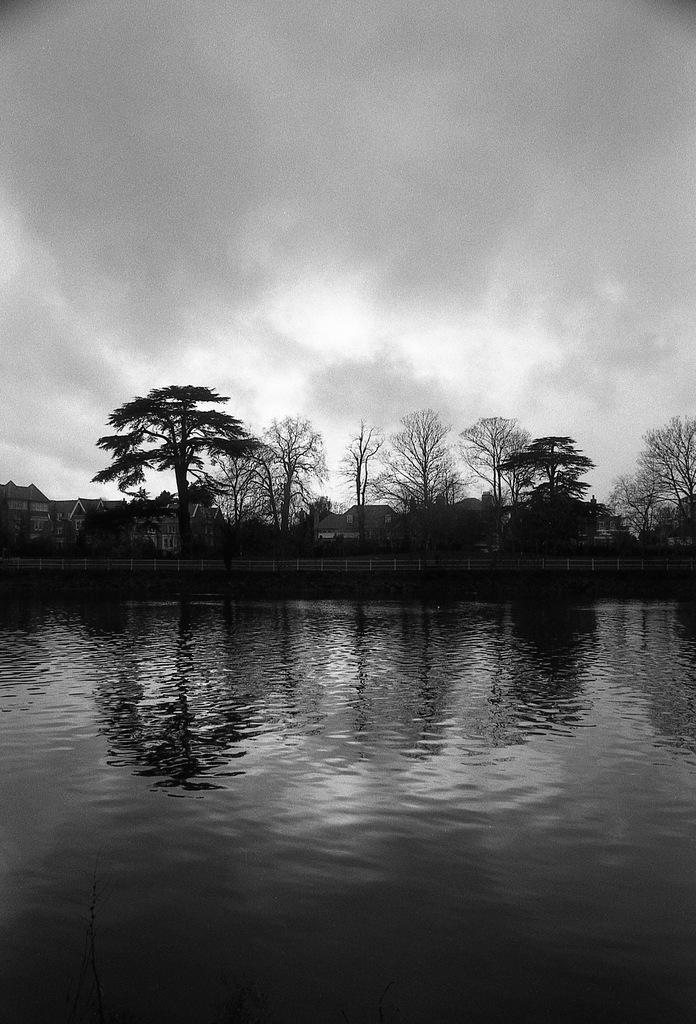What type of body of water is present in the image? There is a lake in the image. What can be seen in the middle of the image? There are trees in the middle of the image. What is visible at the top of the image? The sky is visible at the top of the image. What type of fuel is being used by the rock in the image? There is no rock or fuel present in the image. How does the stream flow through the trees in the image? There is no stream present in the image; it features a lake and trees. 